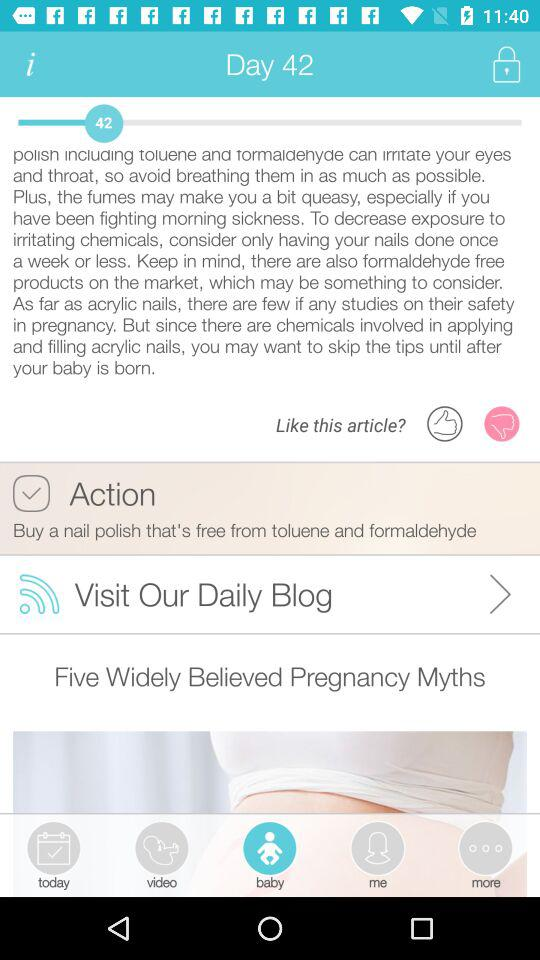How many videos have been uploaded?
When the provided information is insufficient, respond with <no answer>. <no answer> 